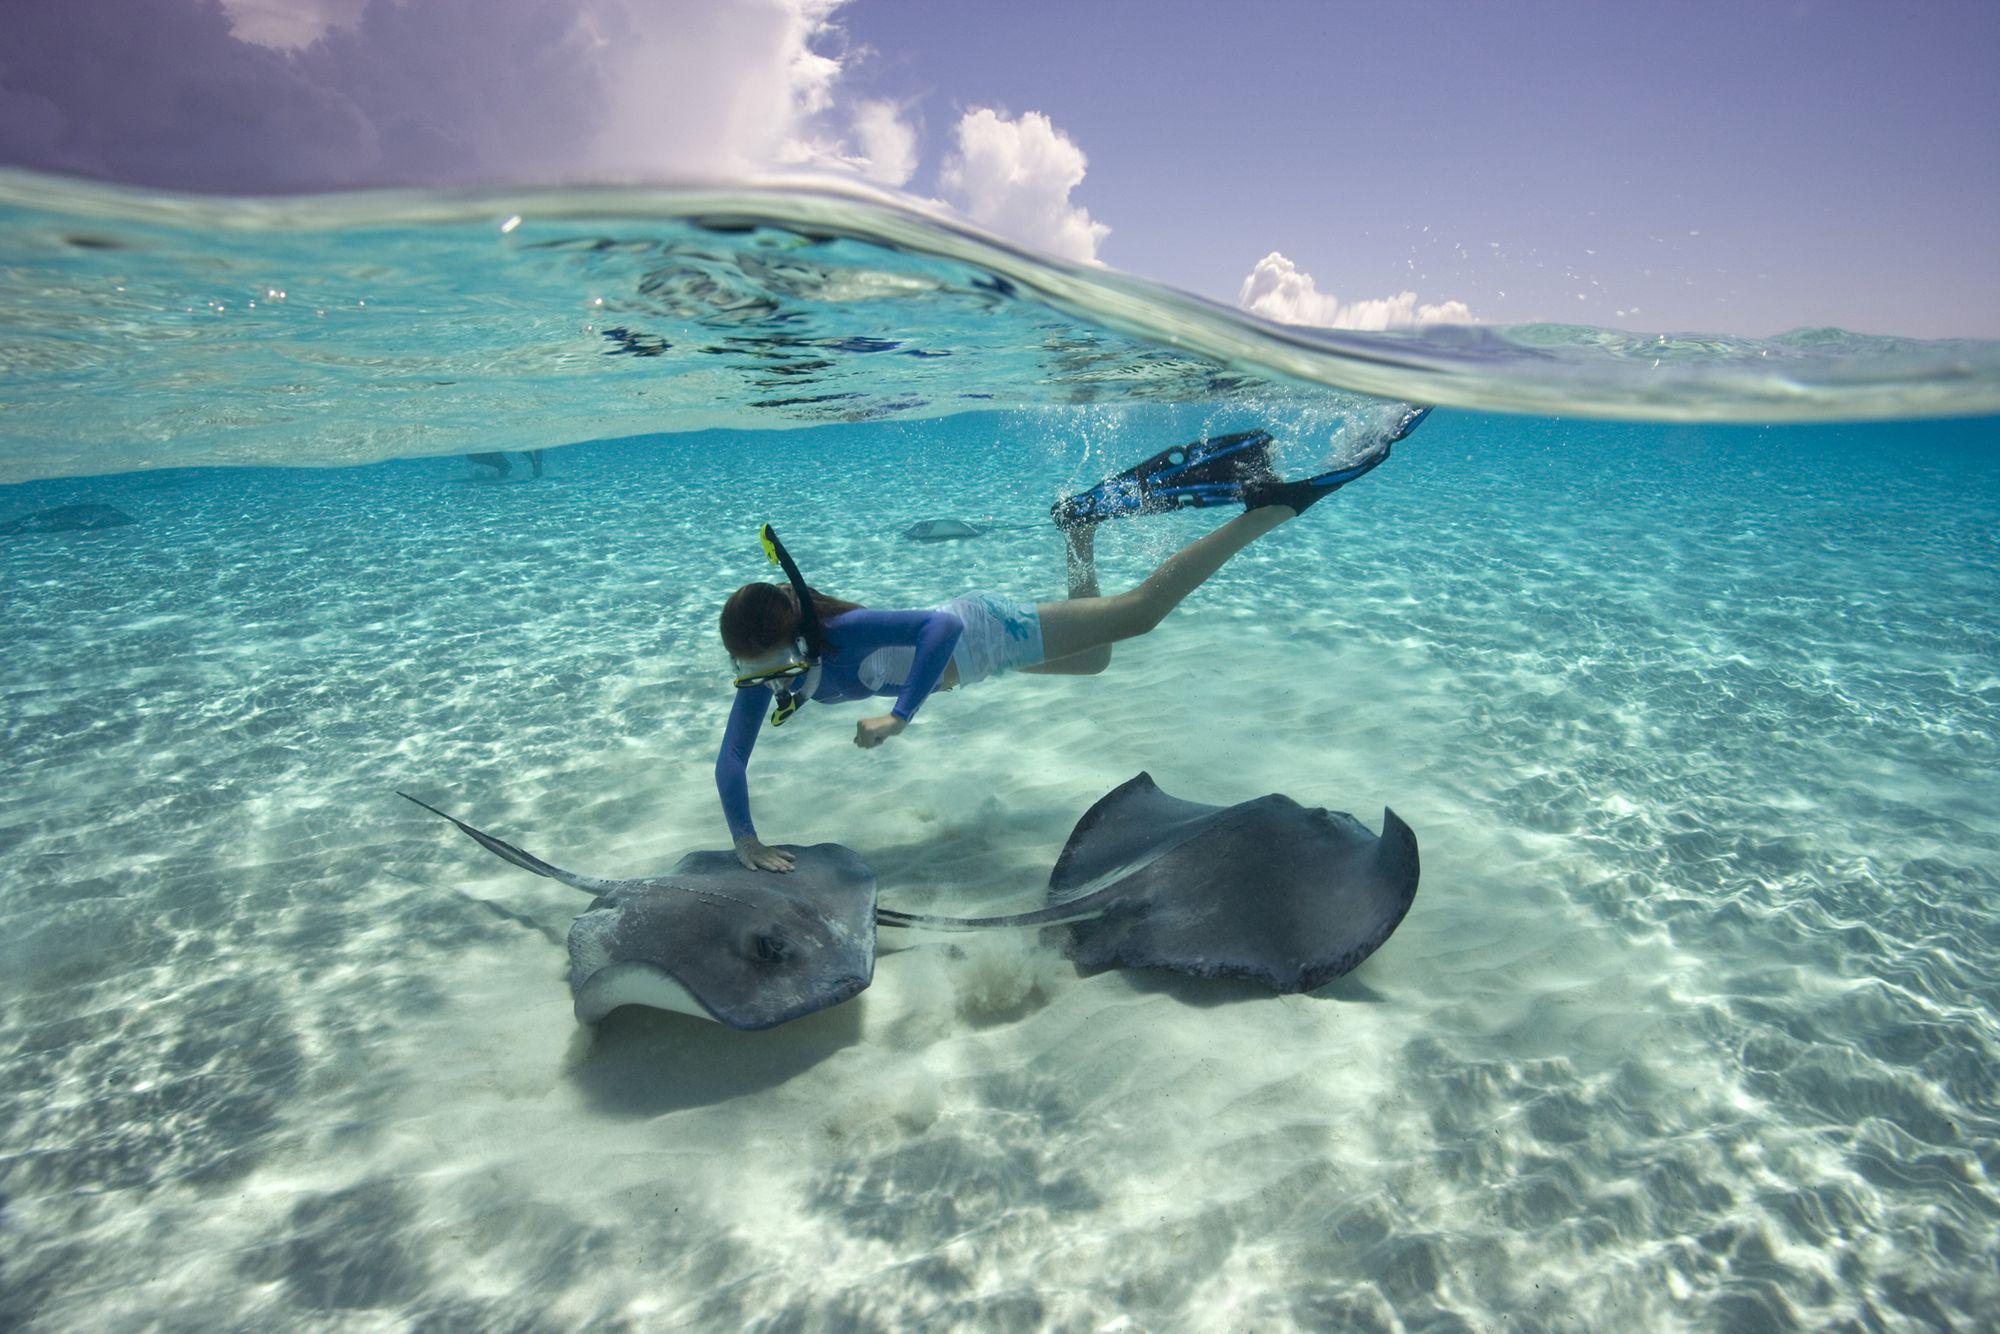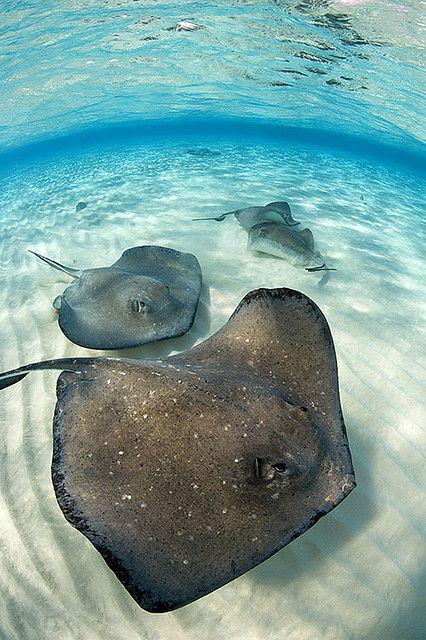The first image is the image on the left, the second image is the image on the right. For the images displayed, is the sentence "One image shows one person with goggles completely underwater near stingrays." factually correct? Answer yes or no. Yes. 